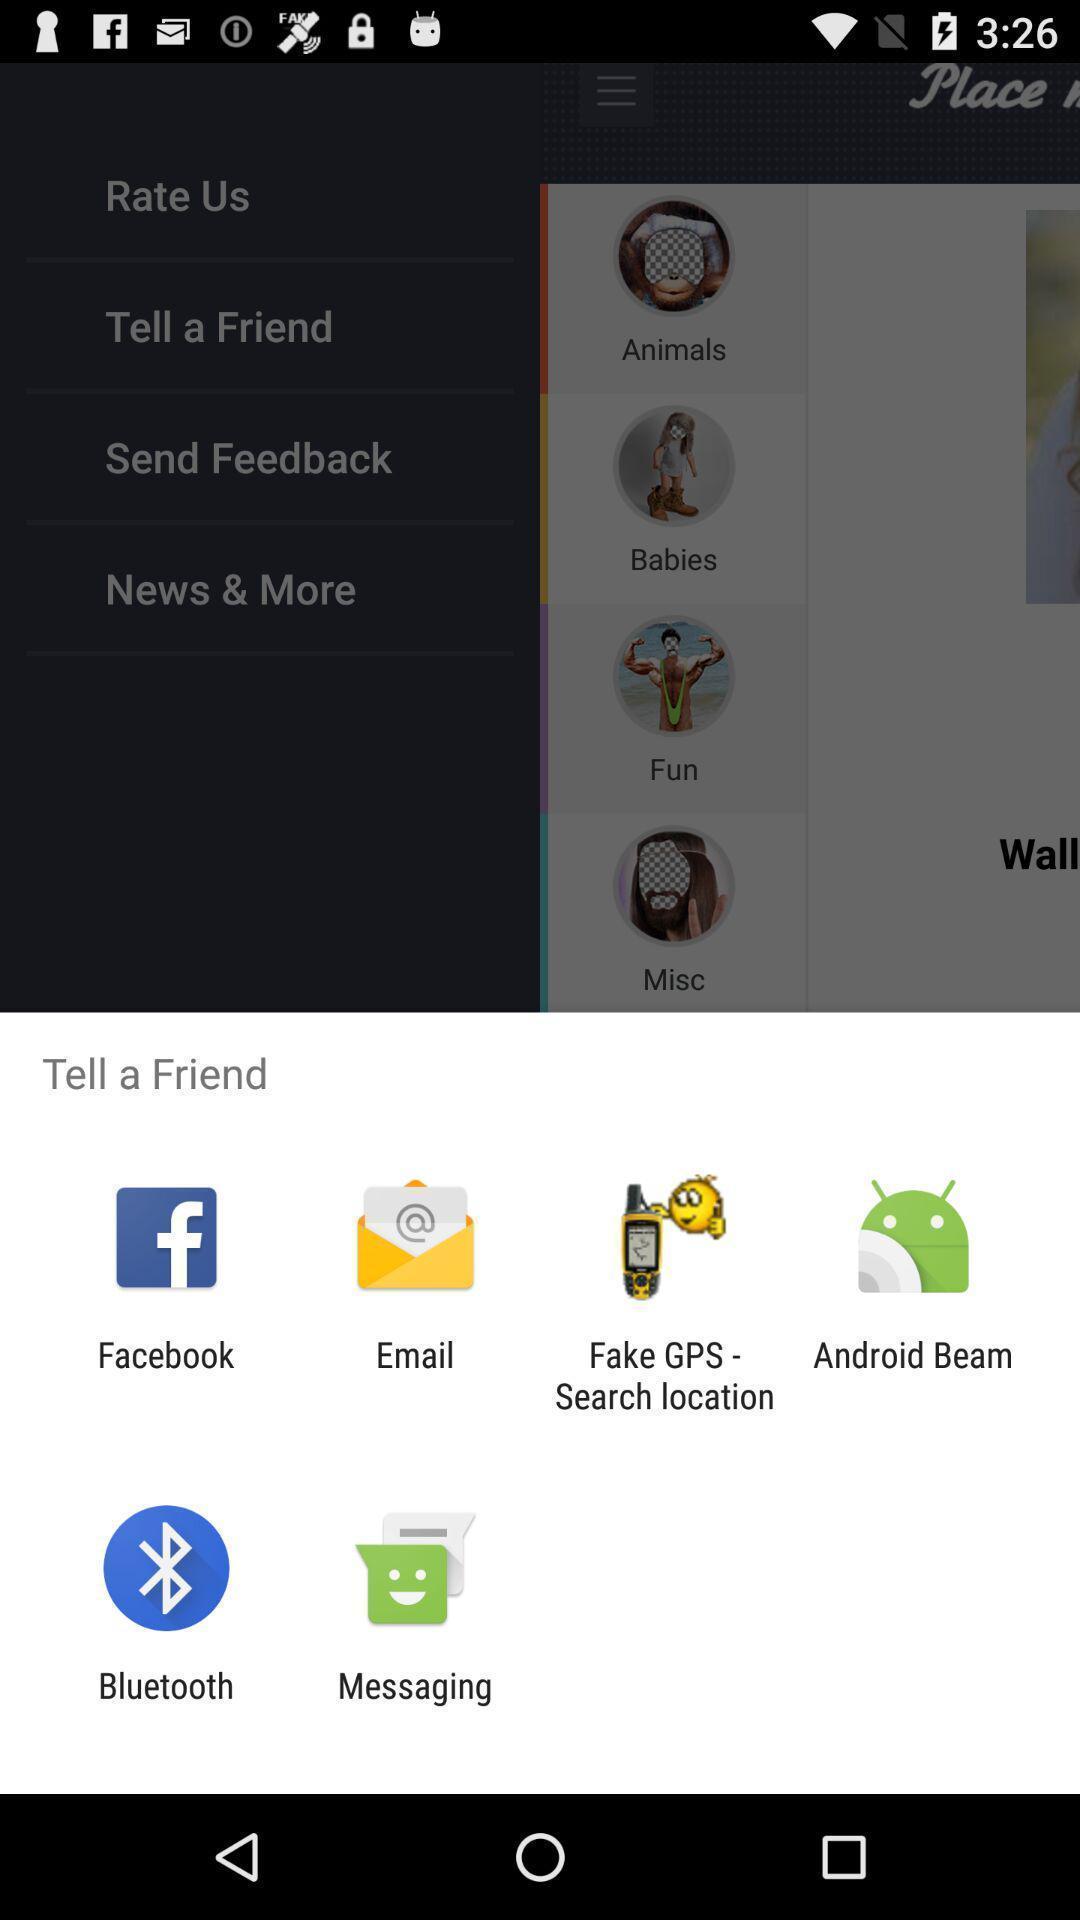Provide a detailed account of this screenshot. Push up page showing app preference to share. 